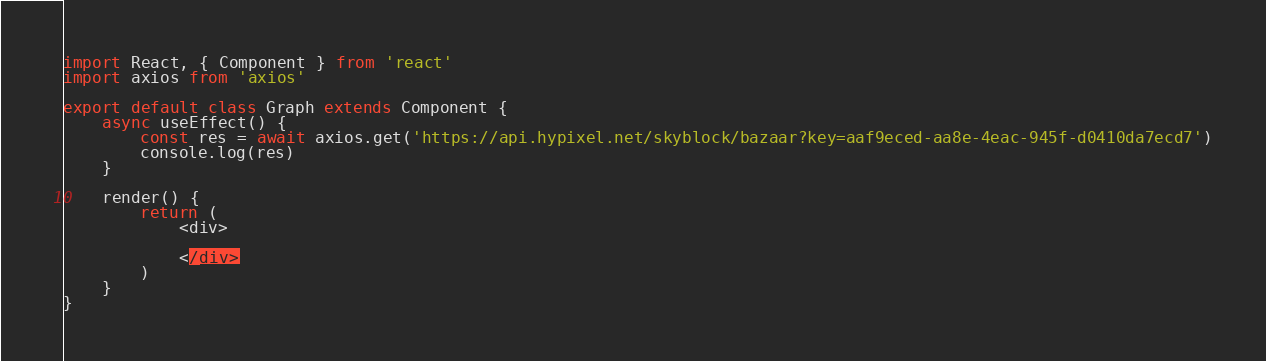Convert code to text. <code><loc_0><loc_0><loc_500><loc_500><_TypeScript_>import React, { Component } from 'react'
import axios from 'axios'

export default class Graph extends Component {
    async useEffect() {
        const res = await axios.get('https://api.hypixel.net/skyblock/bazaar?key=aaf9eced-aa8e-4eac-945f-d0410da7ecd7')
        console.log(res)
    }
    
    render() {
        return (
            <div>
                
            </div>
        )
    }
}
</code> 